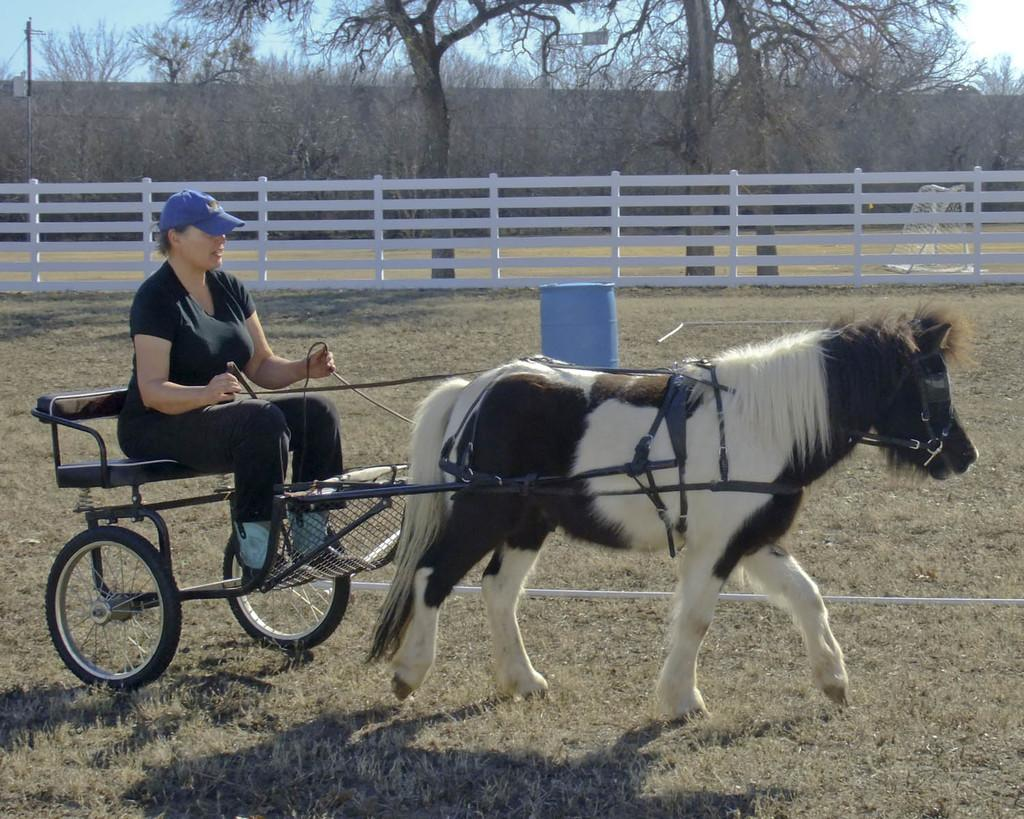What is the main subject of the image? There is a person riding a horse in the image. What object is located behind the person? There is a drum behind the person. What type of barrier is present in the image? There is fencing behind the person. What can be seen in the distance in the image? There are trees visible in the background of the image. What type of pencil does the fireman use to smash the drum in the image? There is no fireman or pencil present in the image, and the drum is not being smashed. 